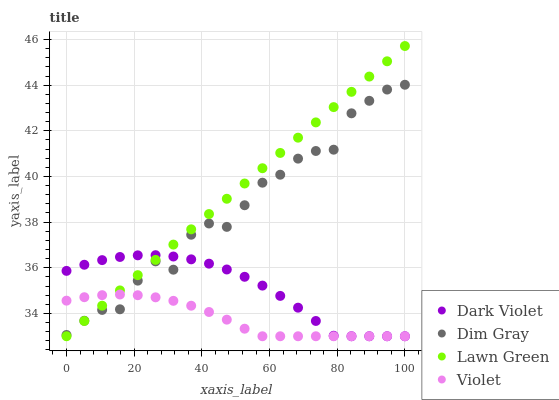Does Violet have the minimum area under the curve?
Answer yes or no. Yes. Does Lawn Green have the maximum area under the curve?
Answer yes or no. Yes. Does Dim Gray have the minimum area under the curve?
Answer yes or no. No. Does Dim Gray have the maximum area under the curve?
Answer yes or no. No. Is Lawn Green the smoothest?
Answer yes or no. Yes. Is Dim Gray the roughest?
Answer yes or no. Yes. Is Dark Violet the smoothest?
Answer yes or no. No. Is Dark Violet the roughest?
Answer yes or no. No. Does Lawn Green have the lowest value?
Answer yes or no. Yes. Does Dim Gray have the lowest value?
Answer yes or no. No. Does Lawn Green have the highest value?
Answer yes or no. Yes. Does Dim Gray have the highest value?
Answer yes or no. No. Does Lawn Green intersect Dim Gray?
Answer yes or no. Yes. Is Lawn Green less than Dim Gray?
Answer yes or no. No. Is Lawn Green greater than Dim Gray?
Answer yes or no. No. 